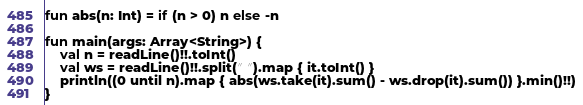Convert code to text. <code><loc_0><loc_0><loc_500><loc_500><_Kotlin_>fun abs(n: Int) = if (n > 0) n else -n

fun main(args: Array<String>) {
    val n = readLine()!!.toInt()
    val ws = readLine()!!.split(" ").map { it.toInt() }
    println((0 until n).map { abs(ws.take(it).sum() - ws.drop(it).sum()) }.min()!!)
}</code> 